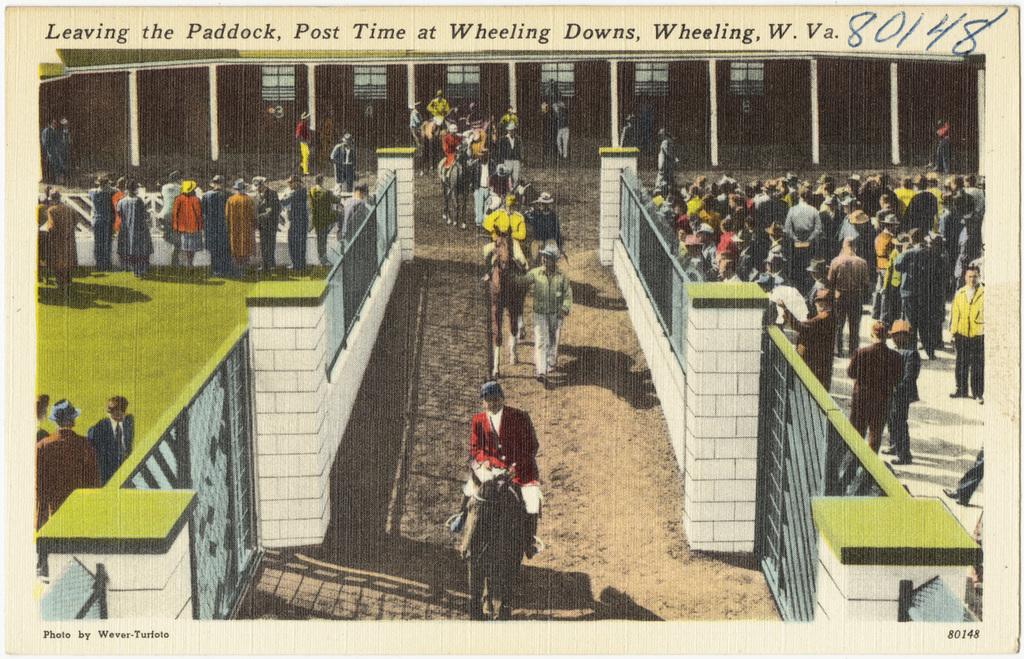What is the 5 digit number shown?
Your response must be concise. 80148. What state is this in?
Ensure brevity in your answer.  West virginia. 